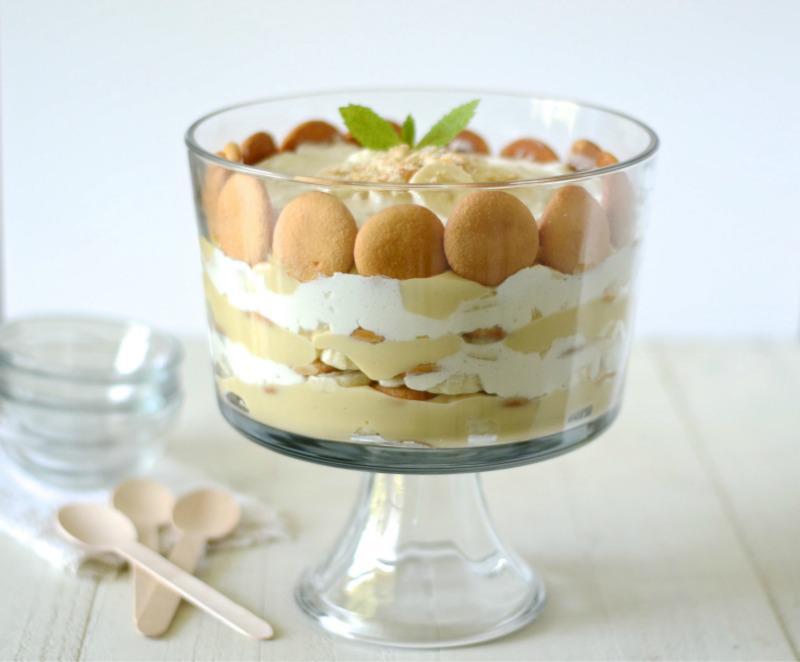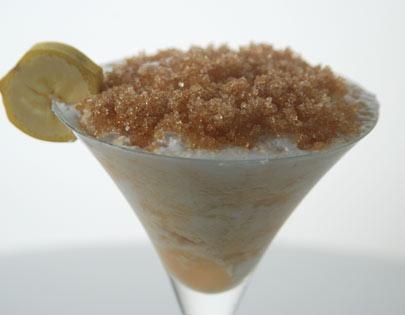The first image is the image on the left, the second image is the image on the right. For the images displayed, is the sentence "There is at least one spoon visible." factually correct? Answer yes or no. Yes. The first image is the image on the left, the second image is the image on the right. Evaluate the accuracy of this statement regarding the images: "There are spoons near a dessert.". Is it true? Answer yes or no. Yes. 